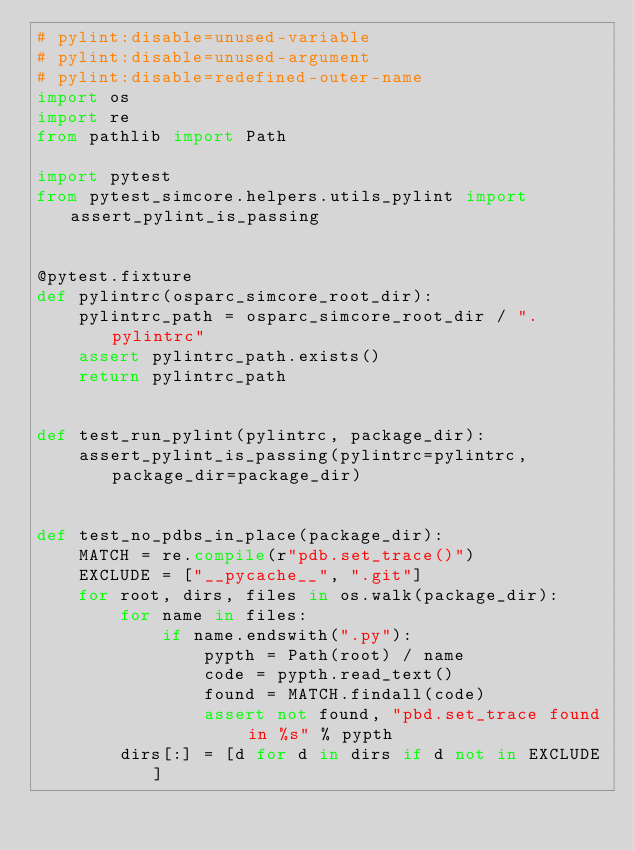Convert code to text. <code><loc_0><loc_0><loc_500><loc_500><_Python_># pylint:disable=unused-variable
# pylint:disable=unused-argument
# pylint:disable=redefined-outer-name
import os
import re
from pathlib import Path

import pytest
from pytest_simcore.helpers.utils_pylint import assert_pylint_is_passing


@pytest.fixture
def pylintrc(osparc_simcore_root_dir):
    pylintrc_path = osparc_simcore_root_dir / ".pylintrc"
    assert pylintrc_path.exists()
    return pylintrc_path


def test_run_pylint(pylintrc, package_dir):
    assert_pylint_is_passing(pylintrc=pylintrc, package_dir=package_dir)


def test_no_pdbs_in_place(package_dir):
    MATCH = re.compile(r"pdb.set_trace()")
    EXCLUDE = ["__pycache__", ".git"]
    for root, dirs, files in os.walk(package_dir):
        for name in files:
            if name.endswith(".py"):
                pypth = Path(root) / name
                code = pypth.read_text()
                found = MATCH.findall(code)
                assert not found, "pbd.set_trace found in %s" % pypth
        dirs[:] = [d for d in dirs if d not in EXCLUDE]
</code> 